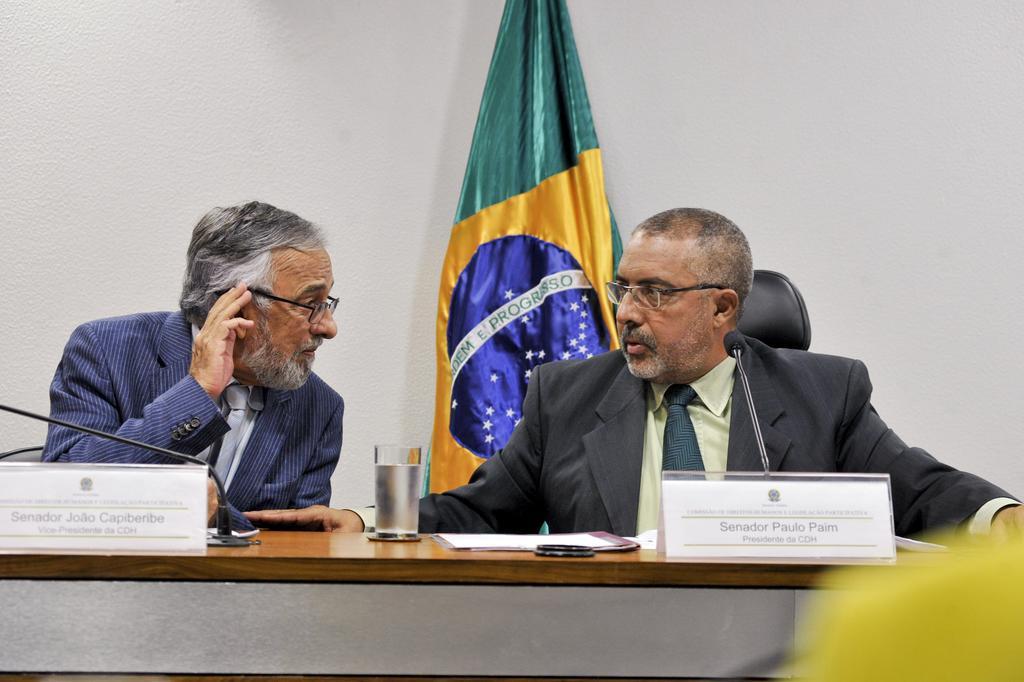Please provide a concise description of this image. In this image I can see two persons visible in front of table, on the table I can see mike and glass, name plate, backside of person I can see the wall , in front of wall I can see a cloth. 